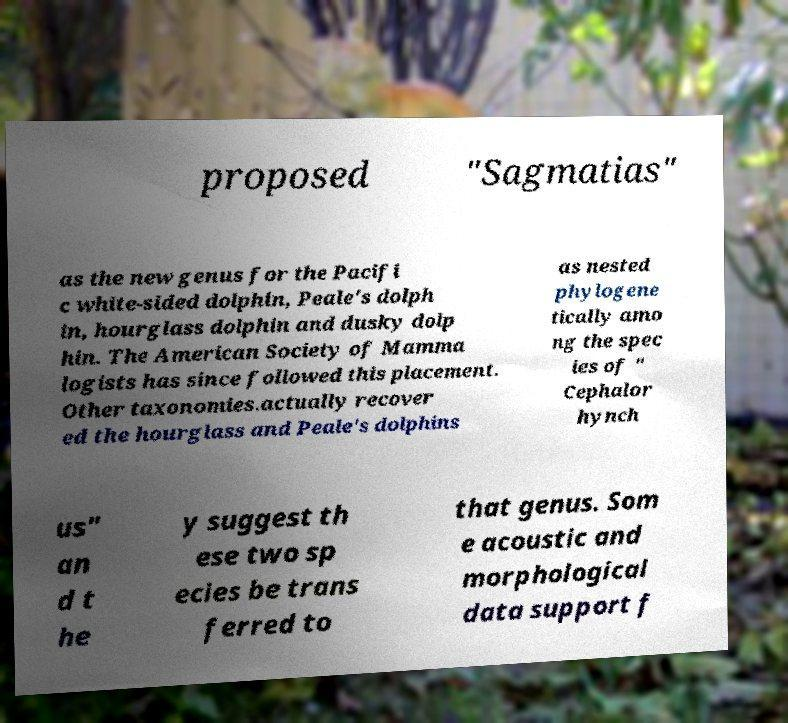For documentation purposes, I need the text within this image transcribed. Could you provide that? proposed "Sagmatias" as the new genus for the Pacifi c white-sided dolphin, Peale's dolph in, hourglass dolphin and dusky dolp hin. The American Society of Mamma logists has since followed this placement. Other taxonomies.actually recover ed the hourglass and Peale's dolphins as nested phylogene tically amo ng the spec ies of " Cephalor hynch us" an d t he y suggest th ese two sp ecies be trans ferred to that genus. Som e acoustic and morphological data support f 